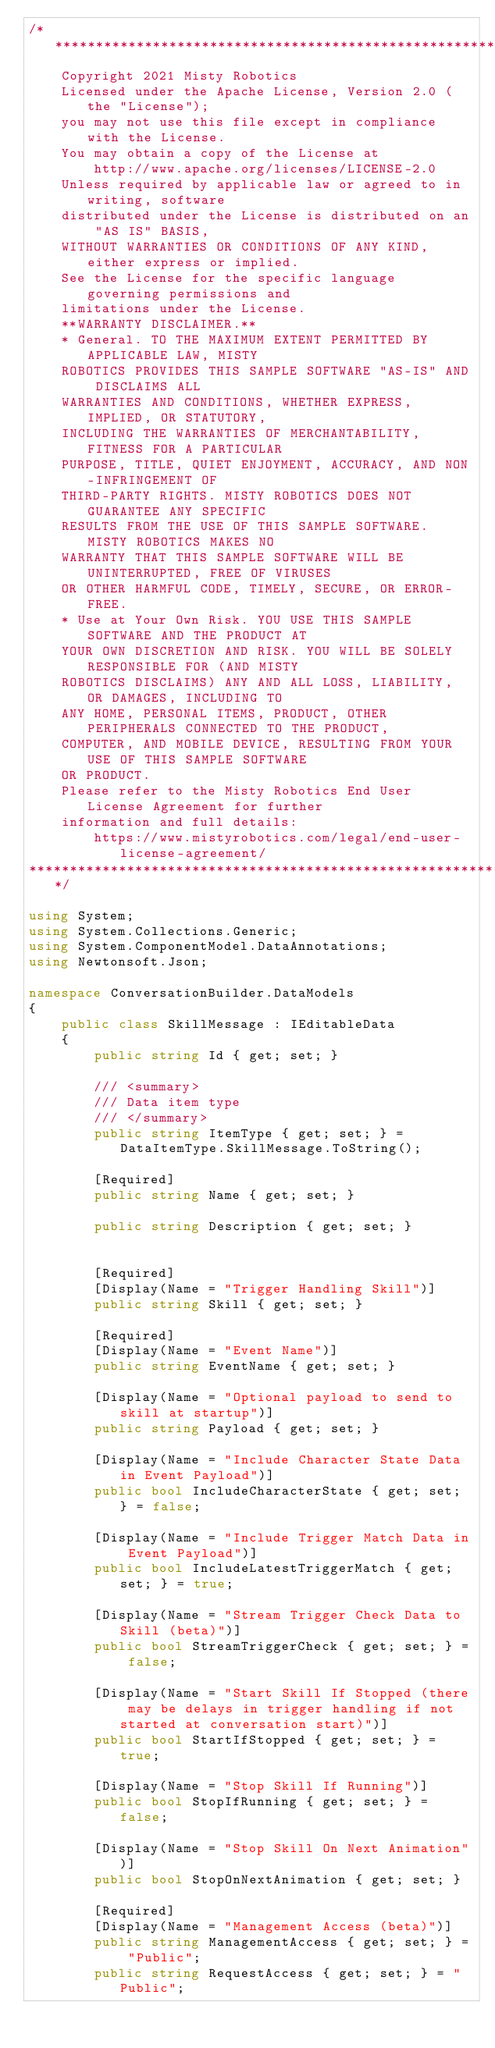<code> <loc_0><loc_0><loc_500><loc_500><_C#_>/**********************************************************************
	Copyright 2021 Misty Robotics
	Licensed under the Apache License, Version 2.0 (the "License");
	you may not use this file except in compliance with the License.
	You may obtain a copy of the License at
		http://www.apache.org/licenses/LICENSE-2.0
	Unless required by applicable law or agreed to in writing, software
	distributed under the License is distributed on an "AS IS" BASIS,
	WITHOUT WARRANTIES OR CONDITIONS OF ANY KIND, either express or implied.
	See the License for the specific language governing permissions and
	limitations under the License.
	**WARRANTY DISCLAIMER.**
	* General. TO THE MAXIMUM EXTENT PERMITTED BY APPLICABLE LAW, MISTY
	ROBOTICS PROVIDES THIS SAMPLE SOFTWARE "AS-IS" AND DISCLAIMS ALL
	WARRANTIES AND CONDITIONS, WHETHER EXPRESS, IMPLIED, OR STATUTORY,
	INCLUDING THE WARRANTIES OF MERCHANTABILITY, FITNESS FOR A PARTICULAR
	PURPOSE, TITLE, QUIET ENJOYMENT, ACCURACY, AND NON-INFRINGEMENT OF
	THIRD-PARTY RIGHTS. MISTY ROBOTICS DOES NOT GUARANTEE ANY SPECIFIC
	RESULTS FROM THE USE OF THIS SAMPLE SOFTWARE. MISTY ROBOTICS MAKES NO
	WARRANTY THAT THIS SAMPLE SOFTWARE WILL BE UNINTERRUPTED, FREE OF VIRUSES
	OR OTHER HARMFUL CODE, TIMELY, SECURE, OR ERROR-FREE.
	* Use at Your Own Risk. YOU USE THIS SAMPLE SOFTWARE AND THE PRODUCT AT
	YOUR OWN DISCRETION AND RISK. YOU WILL BE SOLELY RESPONSIBLE FOR (AND MISTY
	ROBOTICS DISCLAIMS) ANY AND ALL LOSS, LIABILITY, OR DAMAGES, INCLUDING TO
	ANY HOME, PERSONAL ITEMS, PRODUCT, OTHER PERIPHERALS CONNECTED TO THE PRODUCT,
	COMPUTER, AND MOBILE DEVICE, RESULTING FROM YOUR USE OF THIS SAMPLE SOFTWARE
	OR PRODUCT.
	Please refer to the Misty Robotics End User License Agreement for further
	information and full details:
		https://www.mistyrobotics.com/legal/end-user-license-agreement/
**********************************************************************/

using System;
using System.Collections.Generic;
using System.ComponentModel.DataAnnotations;
using Newtonsoft.Json;

namespace ConversationBuilder.DataModels
{
	public class SkillMessage : IEditableData
	{
		public string Id { get; set; }

		/// <summary>
		/// Data item type
		/// </summary>
		public string ItemType { get; set; } = DataItemType.SkillMessage.ToString();
		
		[Required]
		public string Name { get; set; }

		public string Description { get; set; }
		
		
		[Required]
		[Display(Name = "Trigger Handling Skill")]
		public string Skill { get; set; }

		[Required]
		[Display(Name = "Event Name")]
		public string EventName { get; set; }

		[Display(Name = "Optional payload to send to skill at startup")]
		public string Payload { get; set; }

		[Display(Name = "Include Character State Data in Event Payload")]
		public bool IncludeCharacterState { get; set; } = false;

		[Display(Name = "Include Trigger Match Data in Event Payload")]
		public bool IncludeLatestTriggerMatch { get; set; } = true;
		
		[Display(Name = "Stream Trigger Check Data to Skill (beta)")]
		public bool StreamTriggerCheck { get; set; } = false;
		
		[Display(Name = "Start Skill If Stopped (there may be delays in trigger handling if not started at conversation start)")]
		public bool StartIfStopped { get; set; } = true;
		
		[Display(Name = "Stop Skill If Running")]
		public bool StopIfRunning { get; set; } = false;

		[Display(Name = "Stop Skill On Next Animation")]
		public bool StopOnNextAnimation { get; set; }
		
		[Required]
		[Display(Name = "Management Access (beta)")]
		public string ManagementAccess { get; set; } = "Public";
		public string RequestAccess { get; set; } = "Public";
		</code> 